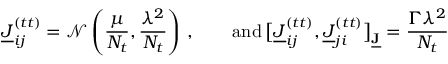<formula> <loc_0><loc_0><loc_500><loc_500>\underline { J } _ { i j } ^ { ( t t ) } = \mathcal { N } \left ( \frac { \mu } { N _ { t } } , \frac { \lambda ^ { 2 } } { N _ { t } } \right ) \, , \quad a n d \, \left [ \underline { J } _ { i j } ^ { ( t t ) } , \underline { J } _ { j i } ^ { ( t t ) } \right ] _ { \underline { J } } = \frac { \Gamma \lambda ^ { 2 } } { N _ { t } }</formula> 